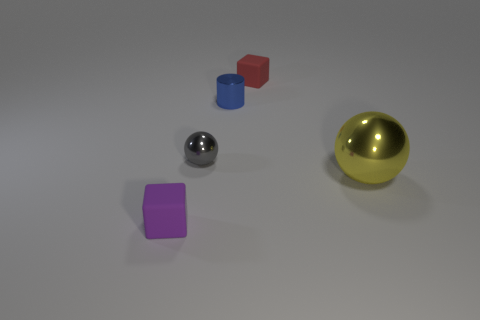Add 1 tiny shiny cylinders. How many objects exist? 6 Subtract all blocks. How many objects are left? 3 Add 1 yellow things. How many yellow things are left? 2 Add 2 gray things. How many gray things exist? 3 Subtract 0 cyan blocks. How many objects are left? 5 Subtract all blue matte cubes. Subtract all metal balls. How many objects are left? 3 